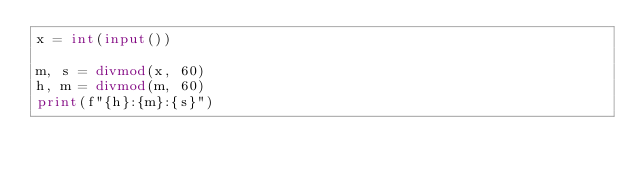Convert code to text. <code><loc_0><loc_0><loc_500><loc_500><_Python_>x = int(input())

m, s = divmod(x, 60)
h, m = divmod(m, 60)
print(f"{h}:{m}:{s}")

</code> 